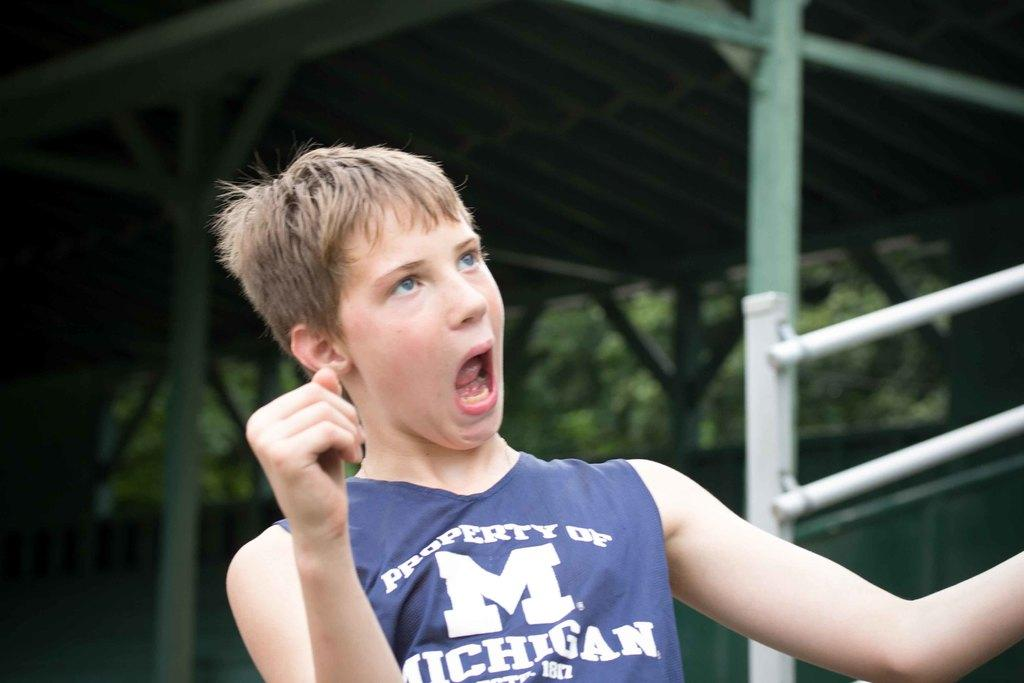<image>
Share a concise interpretation of the image provided. A boy is wearin a a jersey with a capital M on the front of it. 